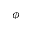<formula> <loc_0><loc_0><loc_500><loc_500>\phi</formula> 